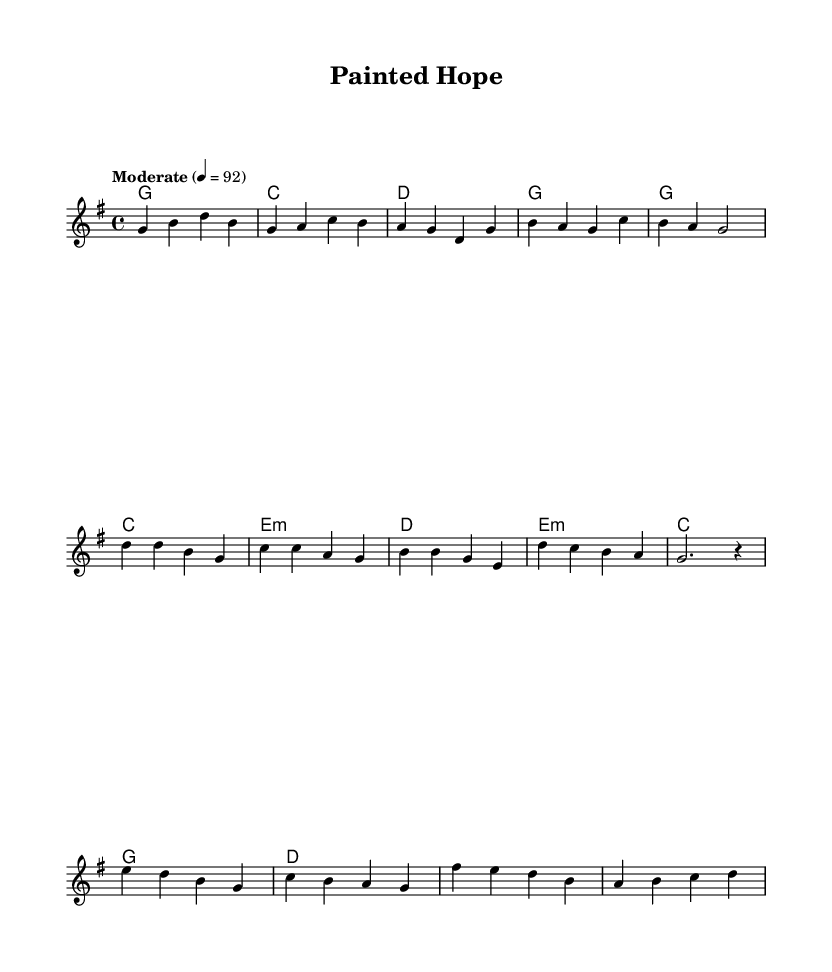What is the key signature of this music? The key signature is G major, which has one sharp (F#). You can identify it by looking at the key signature indication at the beginning of the staff.
Answer: G major What is the time signature of this piece? The time signature is 4/4, which is indicated by the notation at the beginning of the score. This means there are four beats per measure and the quarter note gets one beat.
Answer: 4/4 What is the tempo marking of this music? The tempo marking is "Moderate" at a speed of 92 beats per minute, which is shown at the beginning of the score.
Answer: Moderate, 92 How many measures are in the verse of the piece? The verse consists of four measures, which can be counted by looking at the lines where the music notes are grouped within the verse section indicated.
Answer: 4 What are the primary chords used in the chorus? The primary chords in the chorus are G, C, E minor, and D, as indicated in the harmonies section beneath the melody.
Answer: G, C, E minor, D How many different sections are present in this piece? There are three distinct sections in the piece: verse, chorus, and bridge. This can be determined by identifying the different parts labeled in the sheet music.
Answer: 3 